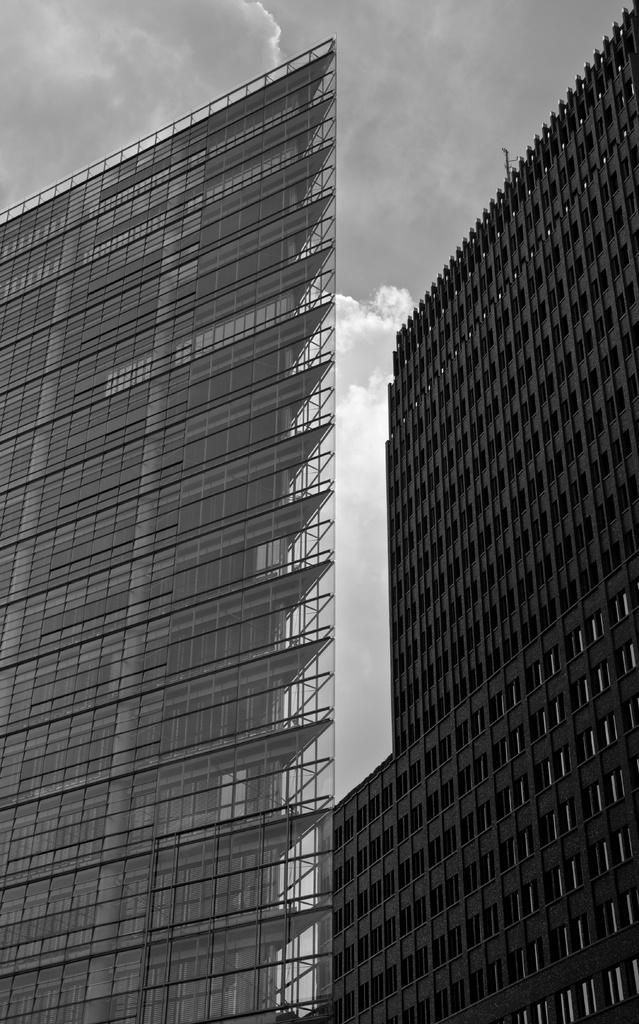What is the color scheme of the image? The image is black and white. What type of structures can be seen in the image? There are big buildings in the image. What objects are present in the image that might be used for support or signage? There are poles in the image. What type of entrance is visible in the image? There are glass doors in the image. What can be seen in the sky in the image? There are clouds in the sky in the image. What is the existence of the father like in the image? There is no reference to a father or any people in the image, so it's not possible to determine the existence of a father. What is the position of the sun in the image? The image is black and white, so it's not possible to determine the position of the sun or any other celestial bodies. 